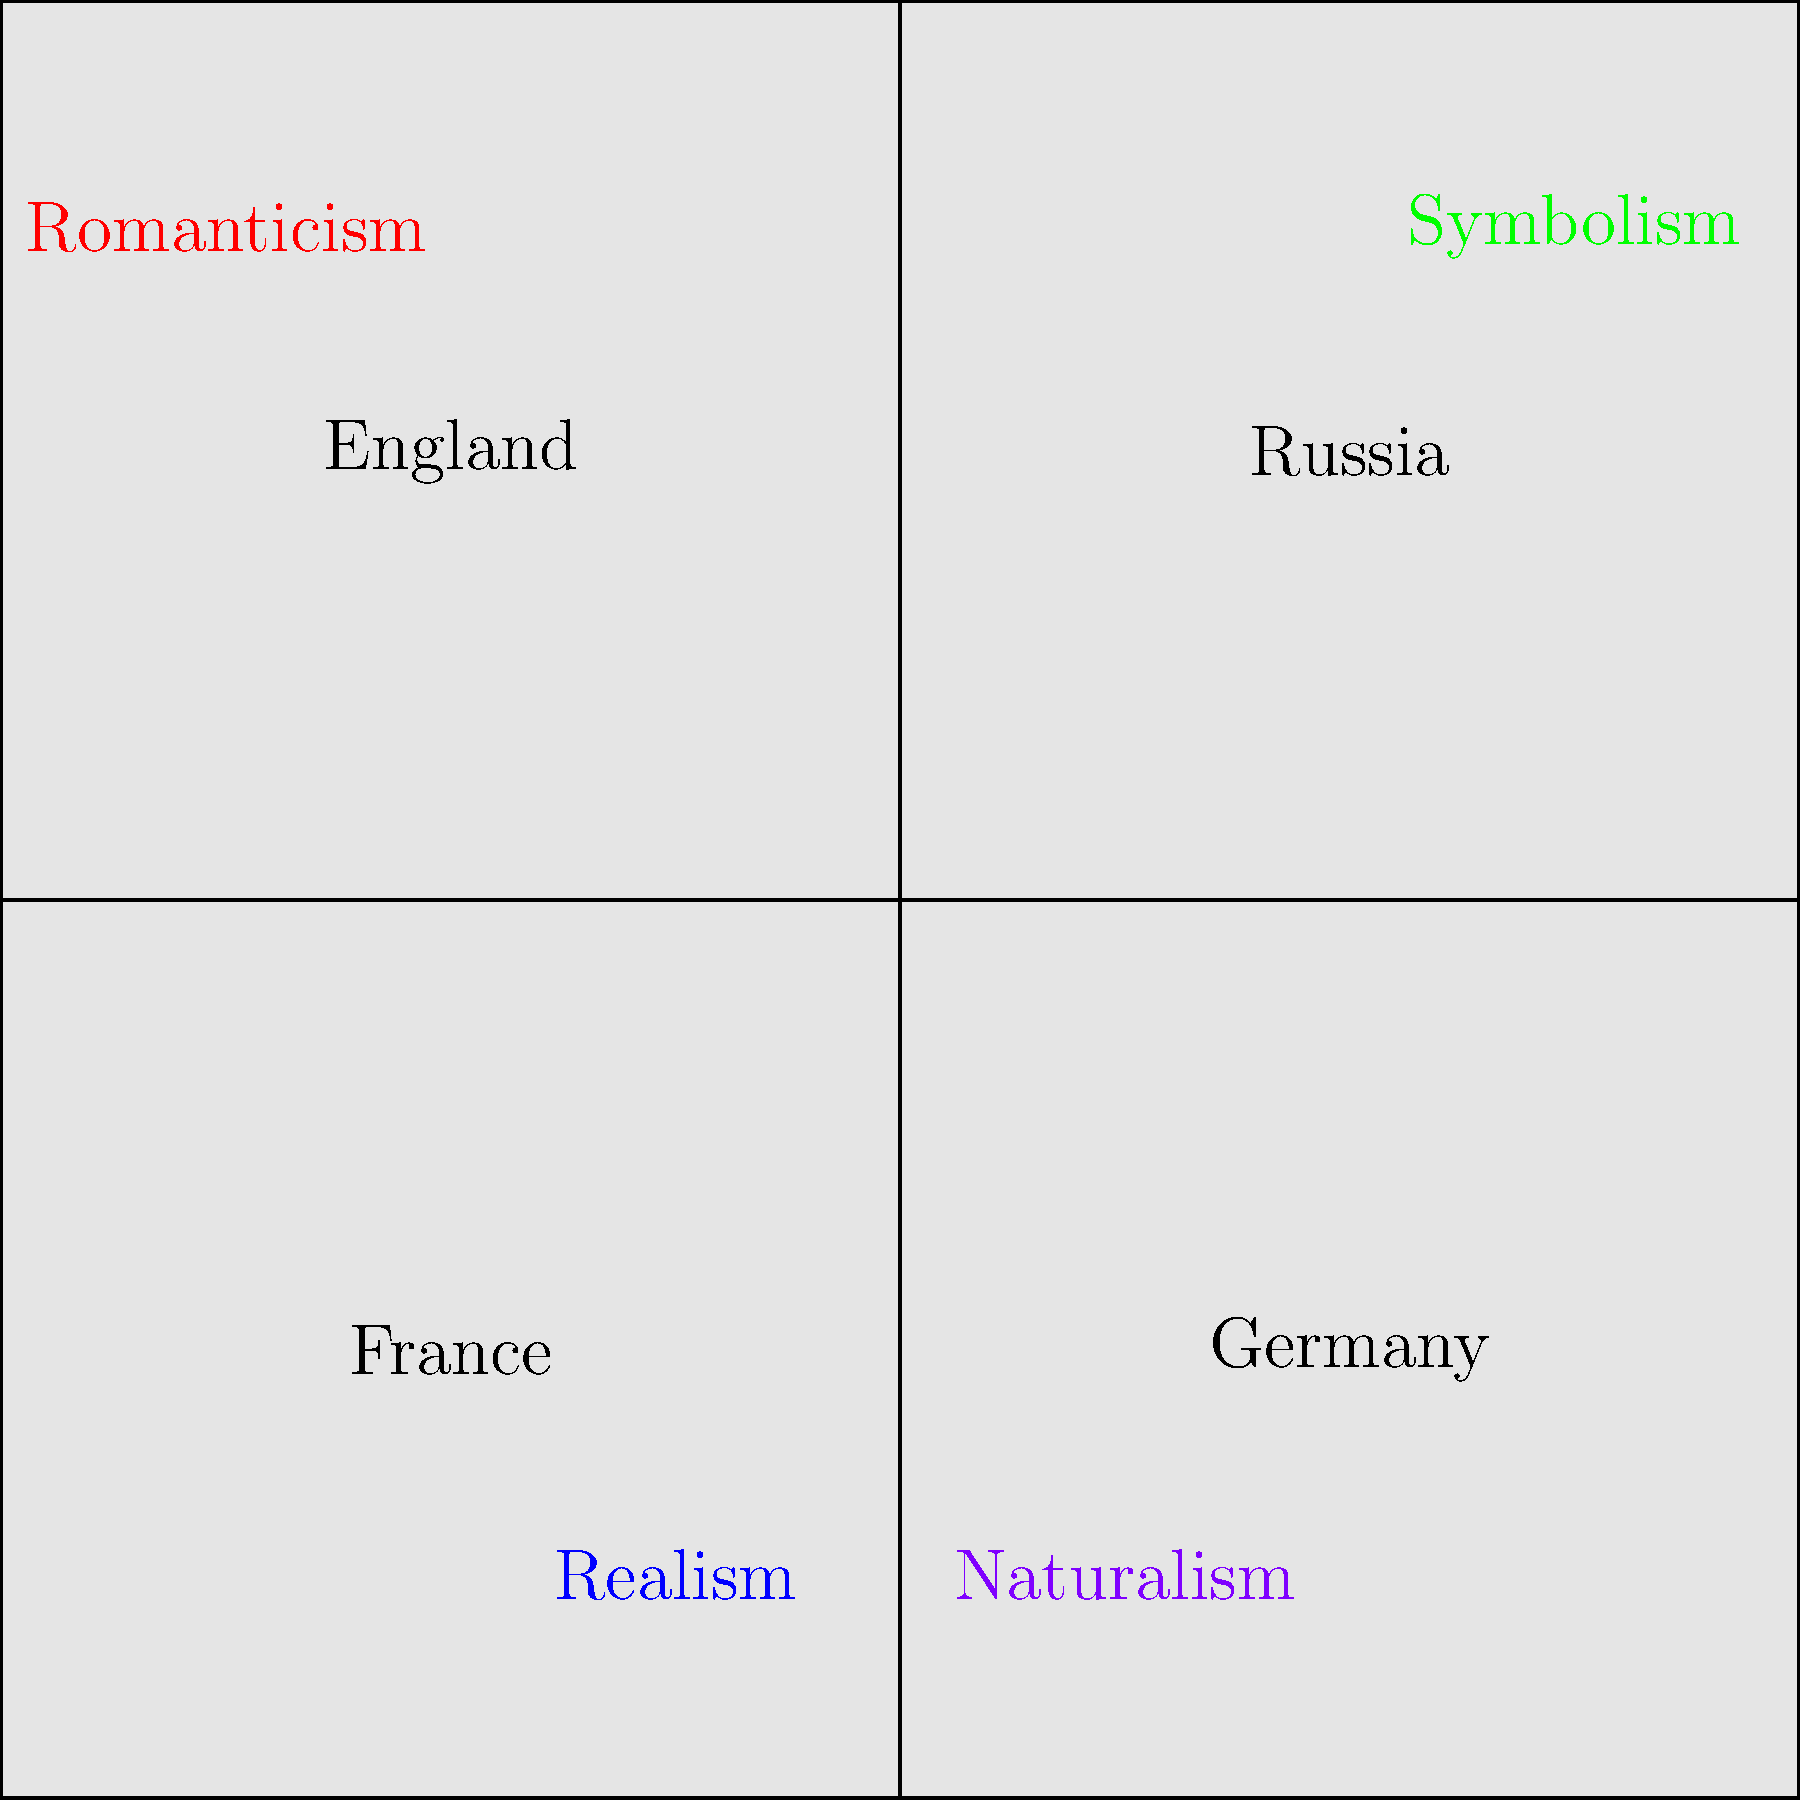Based on the map depicting major literary movements in 19th-century Europe, which movement appears to have originated in France and later spread to other countries? To answer this question, we need to analyze the map and consider the historical context of 19th-century literary movements:

1. The map shows four countries: England, France, Germany, and Russia.
2. Four literary movements are labeled on the map: Romanticism, Realism, Symbolism, and Naturalism.
3. Realism is positioned in France, suggesting its strong association with French literature.
4. Historically, Realism emerged in France in the mid-19th century, primarily as a reaction against Romanticism.
5. Key French Realist authors include Honoré de Balzac, Gustave Flaubert, and Émile Zola.
6. Realism later spread to other European countries, influencing writers such as George Eliot in England, Theodor Fontane in Germany, and Ivan Turgenev in Russia.
7. The positioning of Realism on the map, centered in France but close to the borders of other countries, suggests its origin in France and subsequent spread.

Therefore, based on the map and historical context, Realism appears to be the movement that originated in France and later spread to other countries.
Answer: Realism 